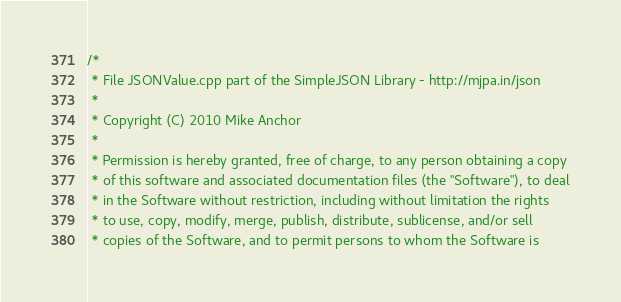<code> <loc_0><loc_0><loc_500><loc_500><_C++_>/*
 * File JSONValue.cpp part of the SimpleJSON Library - http://mjpa.in/json
 *
 * Copyright (C) 2010 Mike Anchor
 *
 * Permission is hereby granted, free of charge, to any person obtaining a copy
 * of this software and associated documentation files (the "Software"), to deal
 * in the Software without restriction, including without limitation the rights
 * to use, copy, modify, merge, publish, distribute, sublicense, and/or sell
 * copies of the Software, and to permit persons to whom the Software is</code> 